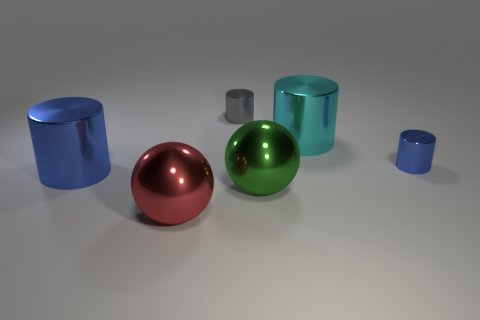Subtract all small gray metal cylinders. How many cylinders are left? 3 Add 1 big brown matte blocks. How many objects exist? 7 Subtract all blue cylinders. How many cylinders are left? 2 Subtract all cylinders. How many objects are left? 2 Subtract 2 spheres. How many spheres are left? 0 Subtract all red balls. How many gray cylinders are left? 1 Subtract all cylinders. Subtract all gray objects. How many objects are left? 1 Add 3 cyan shiny cylinders. How many cyan shiny cylinders are left? 4 Add 1 big brown things. How many big brown things exist? 1 Subtract 0 purple balls. How many objects are left? 6 